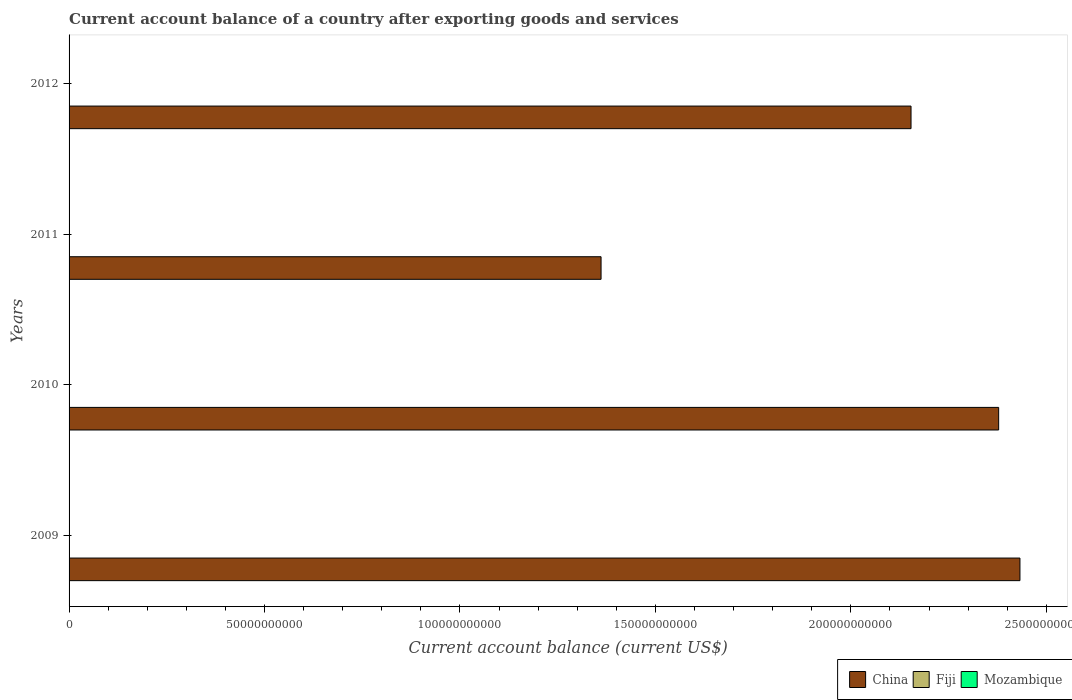How many different coloured bars are there?
Your answer should be very brief. 1. Are the number of bars per tick equal to the number of legend labels?
Provide a short and direct response. No. Are the number of bars on each tick of the Y-axis equal?
Provide a short and direct response. Yes. How many bars are there on the 1st tick from the bottom?
Your answer should be compact. 1. What is the label of the 4th group of bars from the top?
Provide a short and direct response. 2009. In how many cases, is the number of bars for a given year not equal to the number of legend labels?
Provide a succinct answer. 4. Across all years, what is the minimum account balance in China?
Your response must be concise. 1.36e+11. What is the total account balance in China in the graph?
Offer a very short reply. 8.33e+11. What is the difference between the account balance in China in 2009 and that in 2010?
Your answer should be compact. 5.45e+09. What is the average account balance in Fiji per year?
Provide a succinct answer. 0. What is the ratio of the account balance in China in 2010 to that in 2012?
Give a very brief answer. 1.1. Is the account balance in China in 2009 less than that in 2010?
Offer a terse response. No. What is the difference between the highest and the second highest account balance in China?
Offer a very short reply. 5.45e+09. What is the difference between the highest and the lowest account balance in China?
Your answer should be compact. 1.07e+11. Is the sum of the account balance in China in 2010 and 2011 greater than the maximum account balance in Mozambique across all years?
Offer a very short reply. Yes. Are all the bars in the graph horizontal?
Your answer should be compact. Yes. What is the difference between two consecutive major ticks on the X-axis?
Your answer should be very brief. 5.00e+1. Does the graph contain any zero values?
Your answer should be very brief. Yes. How are the legend labels stacked?
Make the answer very short. Horizontal. What is the title of the graph?
Give a very brief answer. Current account balance of a country after exporting goods and services. What is the label or title of the X-axis?
Your response must be concise. Current account balance (current US$). What is the label or title of the Y-axis?
Your answer should be very brief. Years. What is the Current account balance (current US$) of China in 2009?
Offer a very short reply. 2.43e+11. What is the Current account balance (current US$) in China in 2010?
Offer a terse response. 2.38e+11. What is the Current account balance (current US$) in Fiji in 2010?
Offer a very short reply. 0. What is the Current account balance (current US$) of Mozambique in 2010?
Provide a short and direct response. 0. What is the Current account balance (current US$) in China in 2011?
Offer a terse response. 1.36e+11. What is the Current account balance (current US$) of Mozambique in 2011?
Your answer should be compact. 0. What is the Current account balance (current US$) in China in 2012?
Provide a short and direct response. 2.15e+11. What is the Current account balance (current US$) of Fiji in 2012?
Give a very brief answer. 0. What is the Current account balance (current US$) in Mozambique in 2012?
Your response must be concise. 0. Across all years, what is the maximum Current account balance (current US$) of China?
Offer a very short reply. 2.43e+11. Across all years, what is the minimum Current account balance (current US$) of China?
Your answer should be very brief. 1.36e+11. What is the total Current account balance (current US$) of China in the graph?
Your answer should be very brief. 8.33e+11. What is the total Current account balance (current US$) in Mozambique in the graph?
Provide a succinct answer. 0. What is the difference between the Current account balance (current US$) in China in 2009 and that in 2010?
Keep it short and to the point. 5.45e+09. What is the difference between the Current account balance (current US$) of China in 2009 and that in 2011?
Your answer should be very brief. 1.07e+11. What is the difference between the Current account balance (current US$) in China in 2009 and that in 2012?
Offer a terse response. 2.79e+1. What is the difference between the Current account balance (current US$) in China in 2010 and that in 2011?
Offer a terse response. 1.02e+11. What is the difference between the Current account balance (current US$) of China in 2010 and that in 2012?
Your answer should be compact. 2.24e+1. What is the difference between the Current account balance (current US$) of China in 2011 and that in 2012?
Provide a short and direct response. -7.93e+1. What is the average Current account balance (current US$) in China per year?
Offer a very short reply. 2.08e+11. What is the average Current account balance (current US$) of Fiji per year?
Provide a succinct answer. 0. What is the ratio of the Current account balance (current US$) of China in 2009 to that in 2010?
Provide a succinct answer. 1.02. What is the ratio of the Current account balance (current US$) in China in 2009 to that in 2011?
Provide a short and direct response. 1.79. What is the ratio of the Current account balance (current US$) of China in 2009 to that in 2012?
Your answer should be compact. 1.13. What is the ratio of the Current account balance (current US$) in China in 2010 to that in 2011?
Give a very brief answer. 1.75. What is the ratio of the Current account balance (current US$) in China in 2010 to that in 2012?
Ensure brevity in your answer.  1.1. What is the ratio of the Current account balance (current US$) in China in 2011 to that in 2012?
Make the answer very short. 0.63. What is the difference between the highest and the second highest Current account balance (current US$) of China?
Keep it short and to the point. 5.45e+09. What is the difference between the highest and the lowest Current account balance (current US$) in China?
Your answer should be very brief. 1.07e+11. 